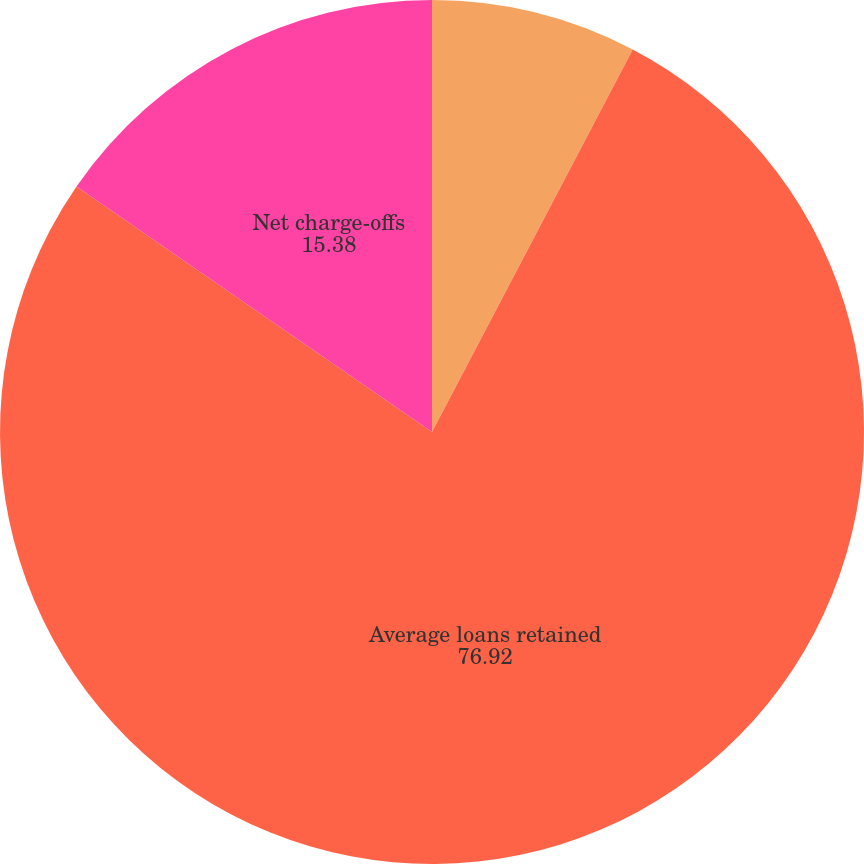Convert chart to OTSL. <chart><loc_0><loc_0><loc_500><loc_500><pie_chart><fcel>Year ended December 31 (in<fcel>Average loans retained<fcel>Net charge-offs<fcel>Average annual net charge-off<nl><fcel>7.69%<fcel>76.92%<fcel>15.38%<fcel>0.0%<nl></chart> 